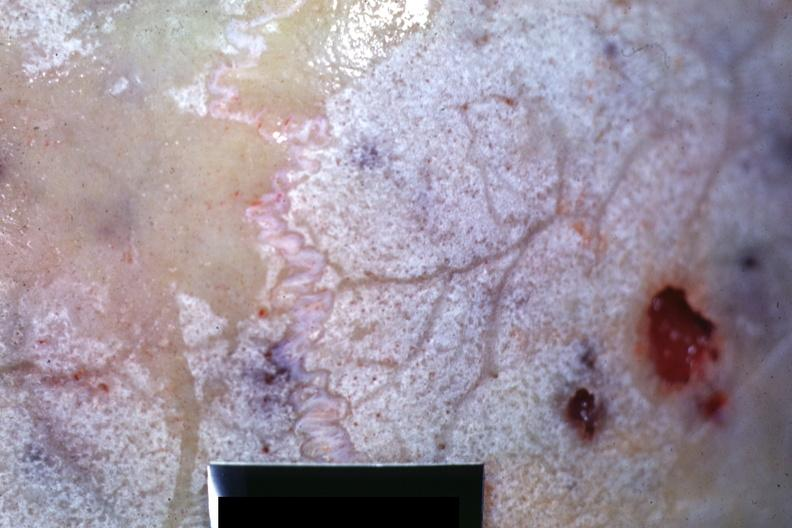how does this image show close-up view of bone?
Answer the question using a single word or phrase. With hemorrhagic excavations 